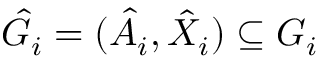Convert formula to latex. <formula><loc_0><loc_0><loc_500><loc_500>\hat { G } _ { i } = ( \hat { A } _ { i } , \hat { X } _ { i } ) \subseteq G _ { i }</formula> 